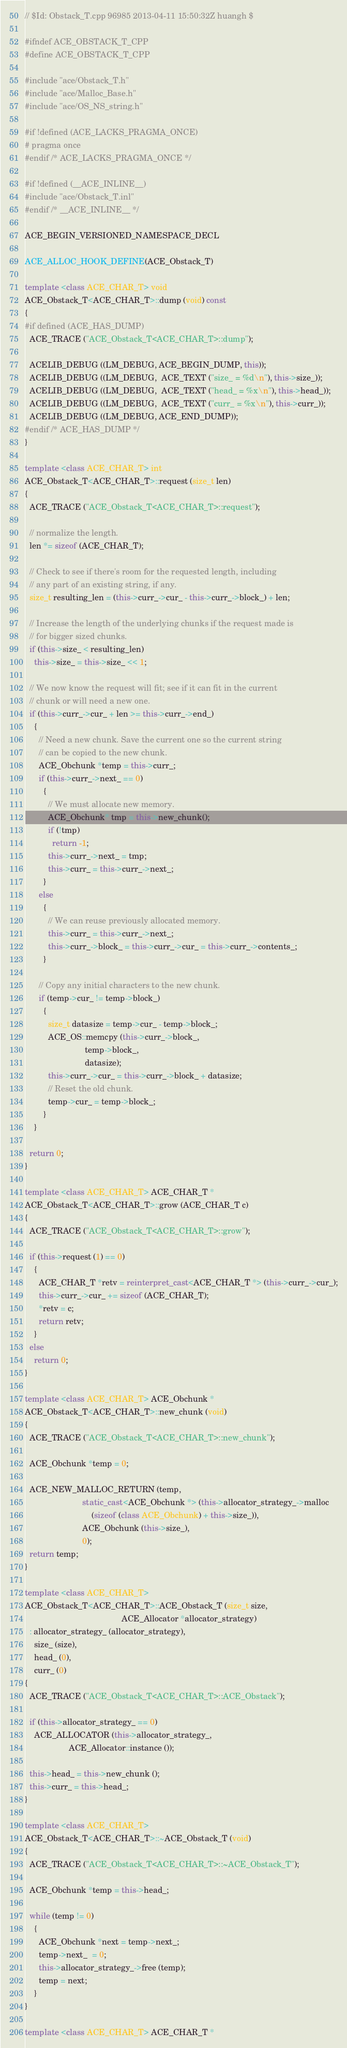<code> <loc_0><loc_0><loc_500><loc_500><_C++_>// $Id: Obstack_T.cpp 96985 2013-04-11 15:50:32Z huangh $

#ifndef ACE_OBSTACK_T_CPP
#define ACE_OBSTACK_T_CPP

#include "ace/Obstack_T.h"
#include "ace/Malloc_Base.h"
#include "ace/OS_NS_string.h"

#if !defined (ACE_LACKS_PRAGMA_ONCE)
# pragma once
#endif /* ACE_LACKS_PRAGMA_ONCE */

#if !defined (__ACE_INLINE__)
#include "ace/Obstack_T.inl"
#endif /* __ACE_INLINE__ */

ACE_BEGIN_VERSIONED_NAMESPACE_DECL

ACE_ALLOC_HOOK_DEFINE(ACE_Obstack_T)

template <class ACE_CHAR_T> void
ACE_Obstack_T<ACE_CHAR_T>::dump (void) const
{
#if defined (ACE_HAS_DUMP)
  ACE_TRACE ("ACE_Obstack_T<ACE_CHAR_T>::dump");

  ACELIB_DEBUG ((LM_DEBUG, ACE_BEGIN_DUMP, this));
  ACELIB_DEBUG ((LM_DEBUG,  ACE_TEXT ("size_ = %d\n"), this->size_));
  ACELIB_DEBUG ((LM_DEBUG,  ACE_TEXT ("head_ = %x\n"), this->head_));
  ACELIB_DEBUG ((LM_DEBUG,  ACE_TEXT ("curr_ = %x\n"), this->curr_));
  ACELIB_DEBUG ((LM_DEBUG, ACE_END_DUMP));
#endif /* ACE_HAS_DUMP */
}

template <class ACE_CHAR_T> int
ACE_Obstack_T<ACE_CHAR_T>::request (size_t len)
{
  ACE_TRACE ("ACE_Obstack_T<ACE_CHAR_T>::request");

  // normalize the length.
  len *= sizeof (ACE_CHAR_T);

  // Check to see if there's room for the requested length, including
  // any part of an existing string, if any.
  size_t resulting_len = (this->curr_->cur_ - this->curr_->block_) + len;

  // Increase the length of the underlying chunks if the request made is
  // for bigger sized chunks.
  if (this->size_ < resulting_len)
    this->size_ = this->size_ << 1;

  // We now know the request will fit; see if it can fit in the current
  // chunk or will need a new one.
  if (this->curr_->cur_ + len >= this->curr_->end_)
    {
      // Need a new chunk. Save the current one so the current string
      // can be copied to the new chunk.
      ACE_Obchunk *temp = this->curr_;
      if (this->curr_->next_ == 0)
        {
          // We must allocate new memory.
          ACE_Obchunk* tmp = this->new_chunk();
          if (!tmp)
            return -1;
          this->curr_->next_ = tmp;
          this->curr_ = this->curr_->next_;
        }
      else
        {
          // We can reuse previously allocated memory.
          this->curr_ = this->curr_->next_;
          this->curr_->block_ = this->curr_->cur_ = this->curr_->contents_;
        }

      // Copy any initial characters to the new chunk.
      if (temp->cur_ != temp->block_)
        {
          size_t datasize = temp->cur_ - temp->block_;
          ACE_OS::memcpy (this->curr_->block_,
                          temp->block_,
                          datasize);
          this->curr_->cur_ = this->curr_->block_ + datasize;
          // Reset the old chunk.
          temp->cur_ = temp->block_;
        }
    }

  return 0;
}

template <class ACE_CHAR_T> ACE_CHAR_T *
ACE_Obstack_T<ACE_CHAR_T>::grow (ACE_CHAR_T c)
{
  ACE_TRACE ("ACE_Obstack_T<ACE_CHAR_T>::grow");

  if (this->request (1) == 0)
    {
      ACE_CHAR_T *retv = reinterpret_cast<ACE_CHAR_T *> (this->curr_->cur_);
      this->curr_->cur_ += sizeof (ACE_CHAR_T);
      *retv = c;
      return retv;
    }
  else
    return 0;
}

template <class ACE_CHAR_T> ACE_Obchunk *
ACE_Obstack_T<ACE_CHAR_T>::new_chunk (void)
{
  ACE_TRACE ("ACE_Obstack_T<ACE_CHAR_T>::new_chunk");

  ACE_Obchunk *temp = 0;

  ACE_NEW_MALLOC_RETURN (temp,
                         static_cast<ACE_Obchunk *> (this->allocator_strategy_->malloc
                             (sizeof (class ACE_Obchunk) + this->size_)),
                         ACE_Obchunk (this->size_),
                         0);
  return temp;
}

template <class ACE_CHAR_T>
ACE_Obstack_T<ACE_CHAR_T>::ACE_Obstack_T (size_t size,
                                          ACE_Allocator *allocator_strategy)
  : allocator_strategy_ (allocator_strategy),
    size_ (size),
    head_ (0),
    curr_ (0)
{
  ACE_TRACE ("ACE_Obstack_T<ACE_CHAR_T>::ACE_Obstack");

  if (this->allocator_strategy_ == 0)
    ACE_ALLOCATOR (this->allocator_strategy_,
                   ACE_Allocator::instance ());

  this->head_ = this->new_chunk ();
  this->curr_ = this->head_;
}

template <class ACE_CHAR_T>
ACE_Obstack_T<ACE_CHAR_T>::~ACE_Obstack_T (void)
{
  ACE_TRACE ("ACE_Obstack_T<ACE_CHAR_T>::~ACE_Obstack_T");

  ACE_Obchunk *temp = this->head_;

  while (temp != 0)
    {
      ACE_Obchunk *next = temp->next_;
      temp->next_  = 0;
      this->allocator_strategy_->free (temp);
      temp = next;
    }
}

template <class ACE_CHAR_T> ACE_CHAR_T *</code> 